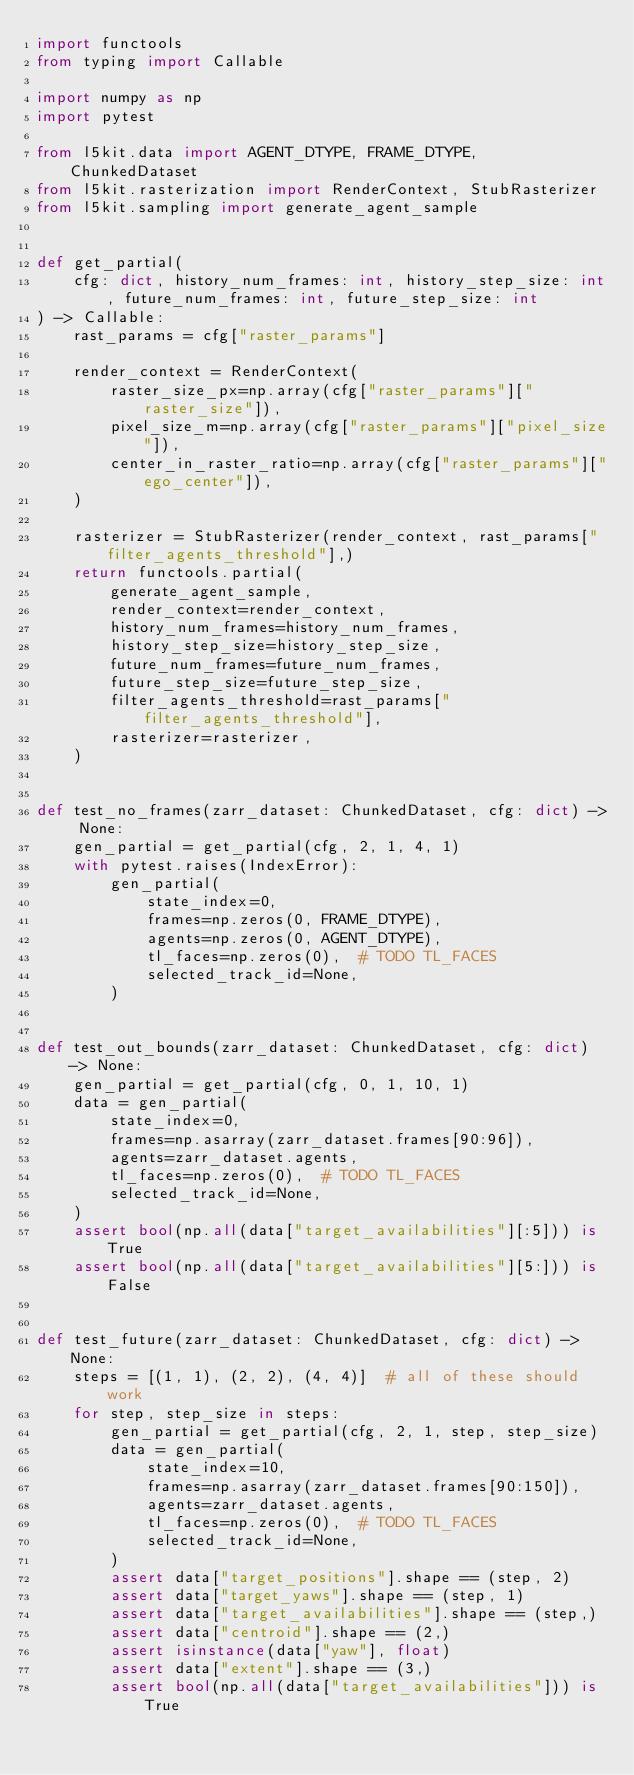Convert code to text. <code><loc_0><loc_0><loc_500><loc_500><_Python_>import functools
from typing import Callable

import numpy as np
import pytest

from l5kit.data import AGENT_DTYPE, FRAME_DTYPE, ChunkedDataset
from l5kit.rasterization import RenderContext, StubRasterizer
from l5kit.sampling import generate_agent_sample


def get_partial(
    cfg: dict, history_num_frames: int, history_step_size: int, future_num_frames: int, future_step_size: int
) -> Callable:
    rast_params = cfg["raster_params"]

    render_context = RenderContext(
        raster_size_px=np.array(cfg["raster_params"]["raster_size"]),
        pixel_size_m=np.array(cfg["raster_params"]["pixel_size"]),
        center_in_raster_ratio=np.array(cfg["raster_params"]["ego_center"]),
    )

    rasterizer = StubRasterizer(render_context, rast_params["filter_agents_threshold"],)
    return functools.partial(
        generate_agent_sample,
        render_context=render_context,
        history_num_frames=history_num_frames,
        history_step_size=history_step_size,
        future_num_frames=future_num_frames,
        future_step_size=future_step_size,
        filter_agents_threshold=rast_params["filter_agents_threshold"],
        rasterizer=rasterizer,
    )


def test_no_frames(zarr_dataset: ChunkedDataset, cfg: dict) -> None:
    gen_partial = get_partial(cfg, 2, 1, 4, 1)
    with pytest.raises(IndexError):
        gen_partial(
            state_index=0,
            frames=np.zeros(0, FRAME_DTYPE),
            agents=np.zeros(0, AGENT_DTYPE),
            tl_faces=np.zeros(0),  # TODO TL_FACES
            selected_track_id=None,
        )


def test_out_bounds(zarr_dataset: ChunkedDataset, cfg: dict) -> None:
    gen_partial = get_partial(cfg, 0, 1, 10, 1)
    data = gen_partial(
        state_index=0,
        frames=np.asarray(zarr_dataset.frames[90:96]),
        agents=zarr_dataset.agents,
        tl_faces=np.zeros(0),  # TODO TL_FACES
        selected_track_id=None,
    )
    assert bool(np.all(data["target_availabilities"][:5])) is True
    assert bool(np.all(data["target_availabilities"][5:])) is False


def test_future(zarr_dataset: ChunkedDataset, cfg: dict) -> None:
    steps = [(1, 1), (2, 2), (4, 4)]  # all of these should work
    for step, step_size in steps:
        gen_partial = get_partial(cfg, 2, 1, step, step_size)
        data = gen_partial(
            state_index=10,
            frames=np.asarray(zarr_dataset.frames[90:150]),
            agents=zarr_dataset.agents,
            tl_faces=np.zeros(0),  # TODO TL_FACES
            selected_track_id=None,
        )
        assert data["target_positions"].shape == (step, 2)
        assert data["target_yaws"].shape == (step, 1)
        assert data["target_availabilities"].shape == (step,)
        assert data["centroid"].shape == (2,)
        assert isinstance(data["yaw"], float)
        assert data["extent"].shape == (3,)
        assert bool(np.all(data["target_availabilities"])) is True
</code> 